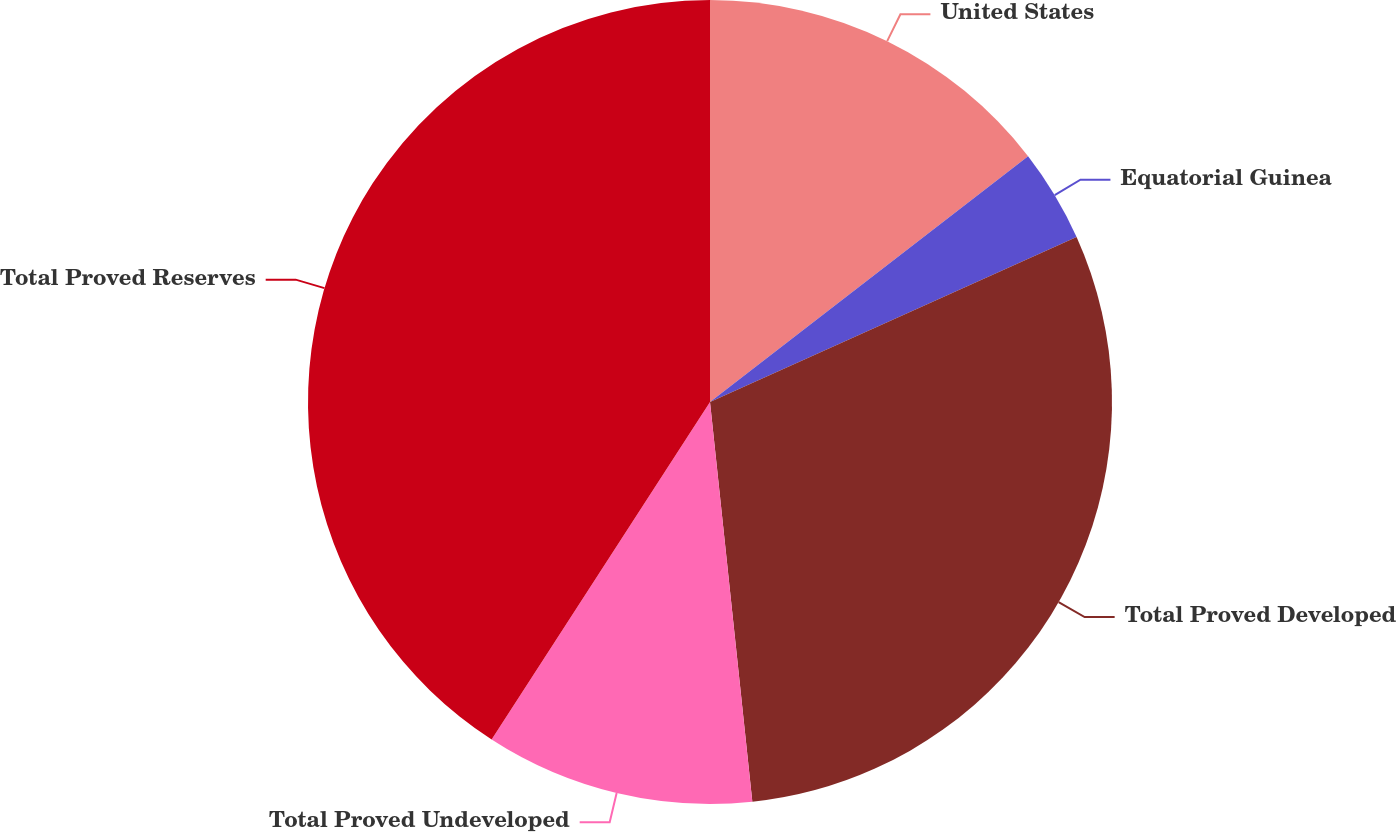Convert chart. <chart><loc_0><loc_0><loc_500><loc_500><pie_chart><fcel>United States<fcel>Equatorial Guinea<fcel>Total Proved Developed<fcel>Total Proved Undeveloped<fcel>Total Proved Reserves<nl><fcel>14.53%<fcel>3.74%<fcel>30.05%<fcel>10.82%<fcel>40.86%<nl></chart> 